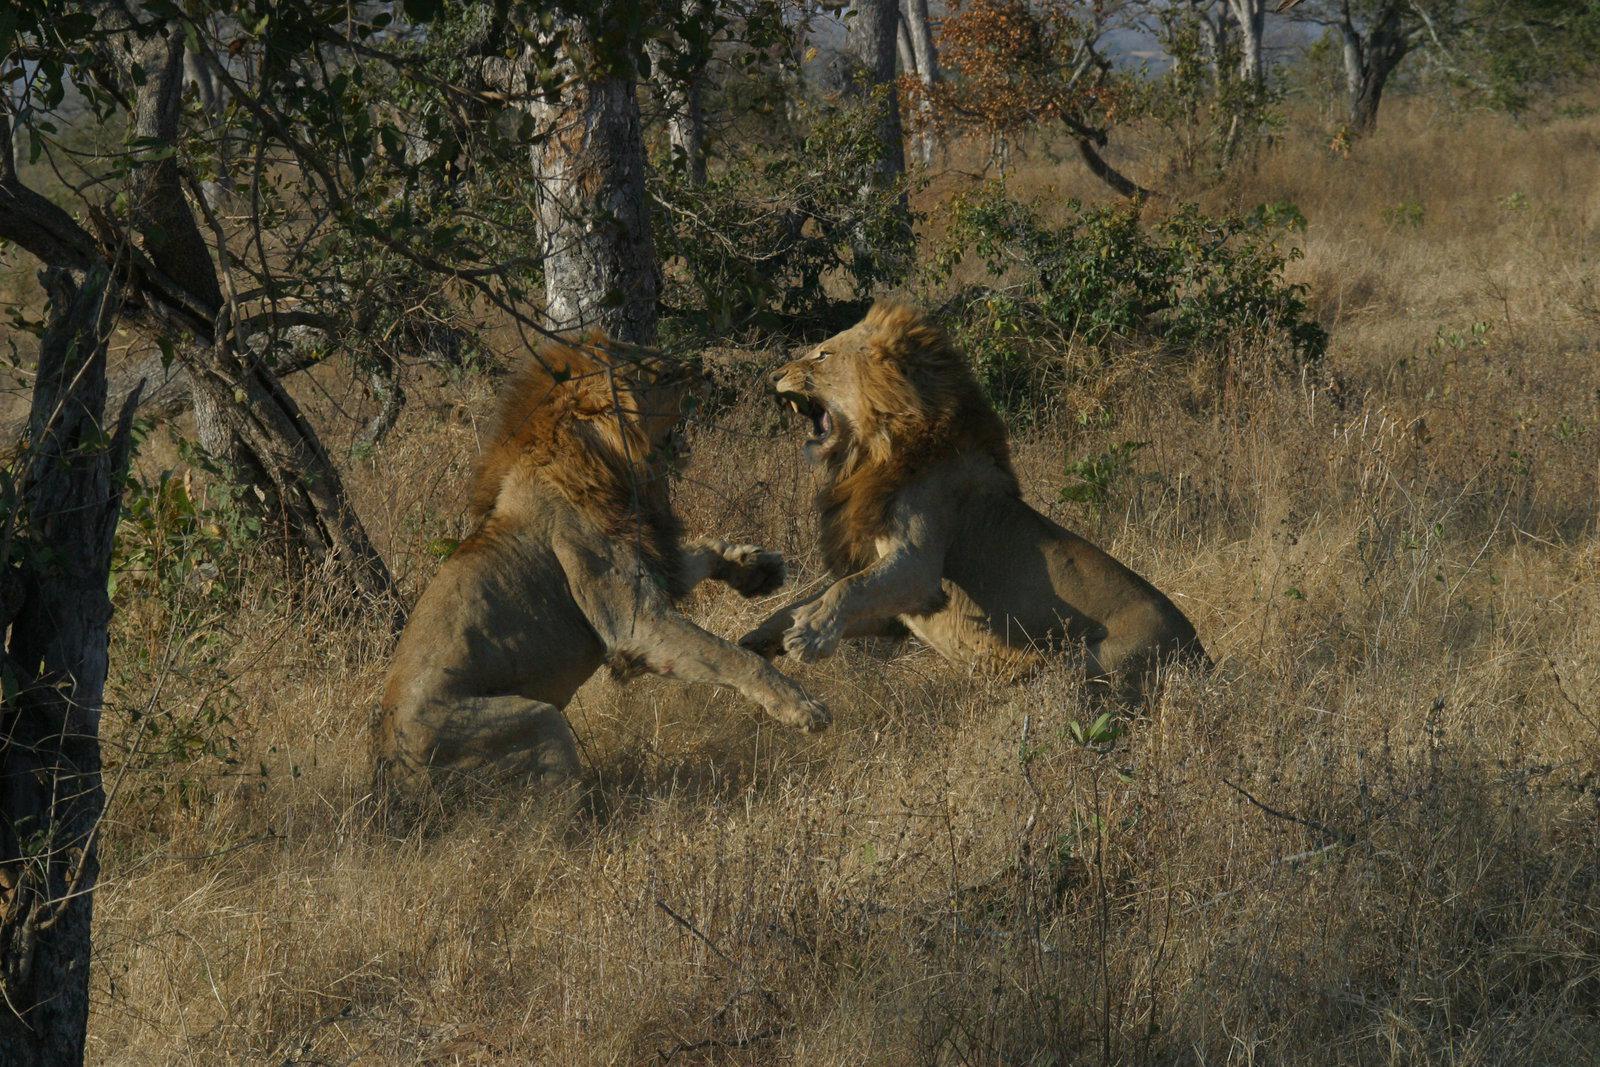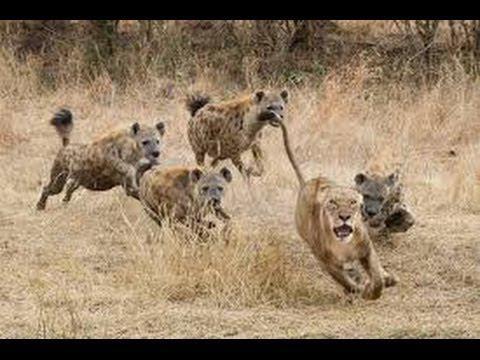The first image is the image on the left, the second image is the image on the right. For the images displayed, is the sentence "The right image contains no more than three hyenas." factually correct? Answer yes or no. No. 